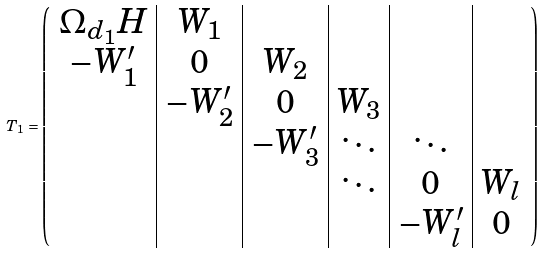<formula> <loc_0><loc_0><loc_500><loc_500>T _ { 1 } = \left ( \begin{array} { c | c | c | c | c | c } \Omega _ { d _ { 1 } } H & W _ { 1 } & & & & \\ - W _ { 1 } ^ { \prime } & 0 & W _ { 2 } & & & \\ & - W _ { 2 } ^ { \prime } & 0 & W _ { 3 } & & \\ & & - W _ { 3 } ^ { \prime } & \ddots & \ddots & \\ & & & \ddots & 0 & W _ { l } \\ & & & & - W _ { l } ^ { \prime } & 0 \end{array} \right )</formula> 